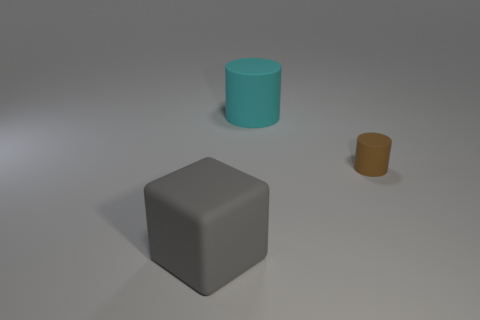Add 1 cylinders. How many objects exist? 4 Subtract all brown cylinders. How many cylinders are left? 1 Subtract all cylinders. How many objects are left? 1 Subtract 1 cubes. How many cubes are left? 0 Subtract all brown cylinders. Subtract all cyan spheres. How many cylinders are left? 1 Subtract all gray blocks. How many yellow cylinders are left? 0 Subtract all tiny brown cylinders. Subtract all big cyan matte things. How many objects are left? 1 Add 1 small brown matte things. How many small brown matte things are left? 2 Add 3 small metal balls. How many small metal balls exist? 3 Subtract 0 red cubes. How many objects are left? 3 